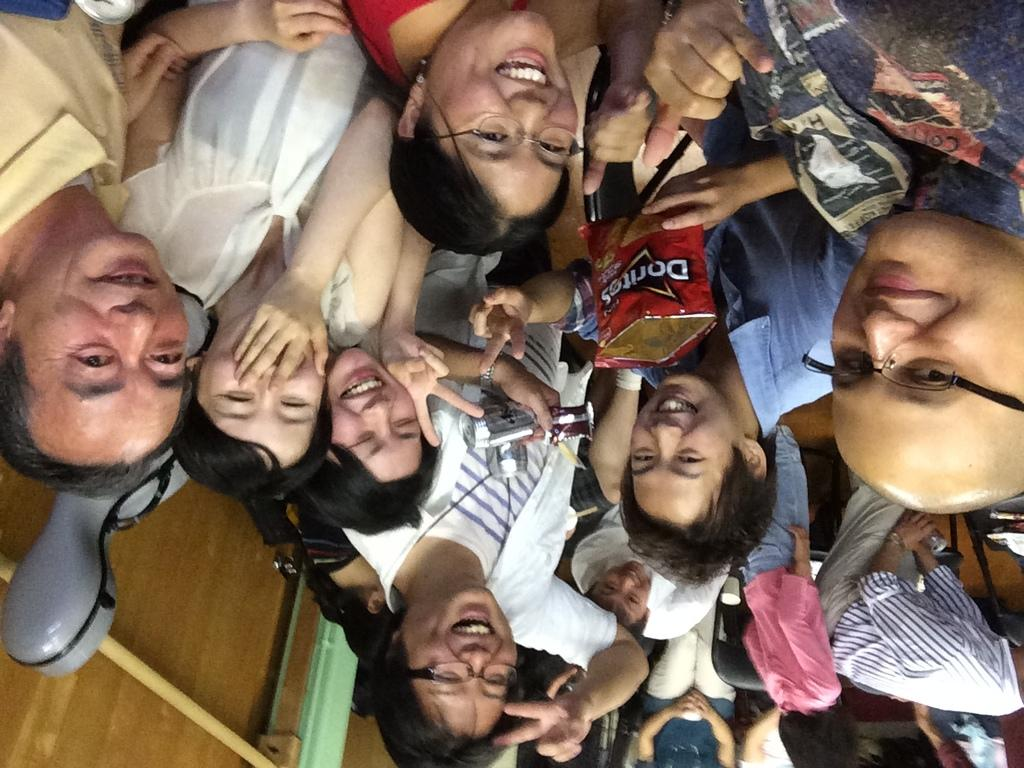What is the main subject of the image? There is a group of people in the image. What can be seen in the background of the image? There are walls and a floor visible in the background of the image. Are there any objects in the background of the image? Yes, there is a chair in the background of the image. What type of sign can be seen in the hands of the people in the image? There is no sign visible in the hands of the people in the image. What kind of harmony is being played by the group of people in the image? There is no indication of music or harmony in the image; it only shows a group of people. 